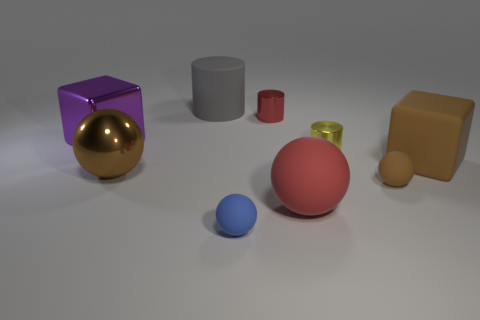Add 1 small yellow objects. How many objects exist? 10 Subtract all spheres. How many objects are left? 5 Subtract 0 gray spheres. How many objects are left? 9 Subtract all tiny green matte spheres. Subtract all cylinders. How many objects are left? 6 Add 3 rubber things. How many rubber things are left? 8 Add 9 purple cylinders. How many purple cylinders exist? 9 